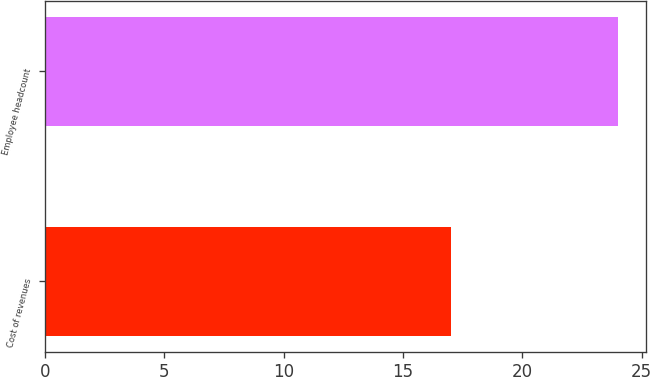Convert chart. <chart><loc_0><loc_0><loc_500><loc_500><bar_chart><fcel>Cost of revenues<fcel>Employee headcount<nl><fcel>17<fcel>24<nl></chart> 